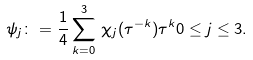<formula> <loc_0><loc_0><loc_500><loc_500>\psi _ { j } \colon = \frac { 1 } { 4 } \sum _ { k = 0 } ^ { 3 } \, \chi _ { j } ( \tau ^ { - k } ) \tau ^ { k } 0 \leq j \leq 3 .</formula> 